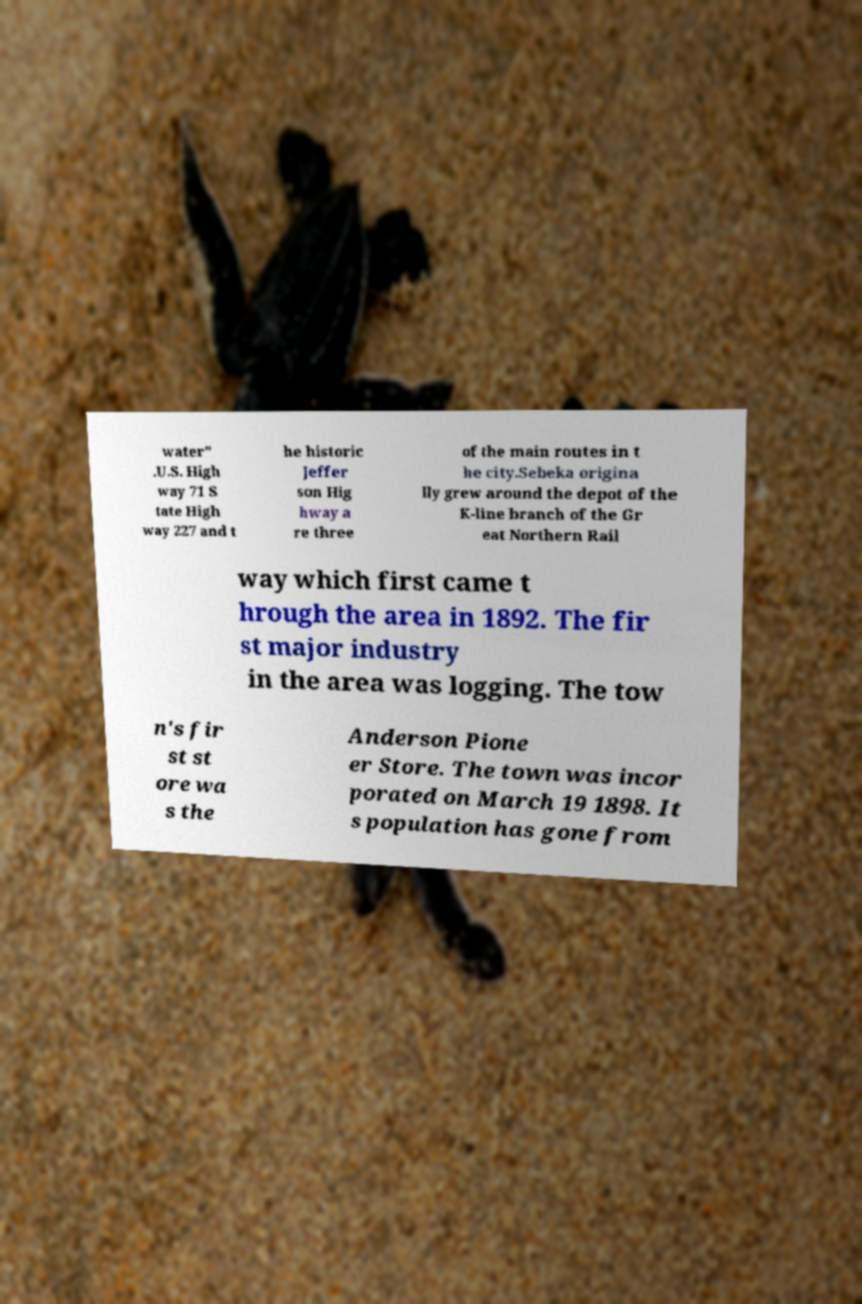For documentation purposes, I need the text within this image transcribed. Could you provide that? water" .U.S. High way 71 S tate High way 227 and t he historic Jeffer son Hig hway a re three of the main routes in t he city.Sebeka origina lly grew around the depot of the K-line branch of the Gr eat Northern Rail way which first came t hrough the area in 1892. The fir st major industry in the area was logging. The tow n's fir st st ore wa s the Anderson Pione er Store. The town was incor porated on March 19 1898. It s population has gone from 